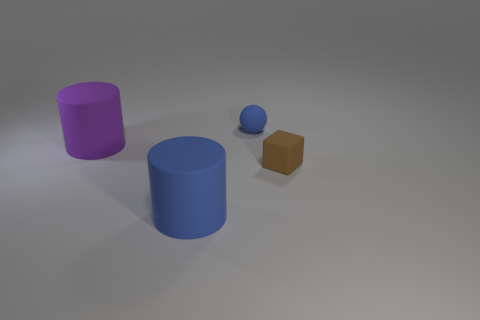There is a thing that is the same color as the matte sphere; what is its shape?
Offer a terse response. Cylinder. There is another object that is the same shape as the large blue rubber thing; what is it made of?
Give a very brief answer. Rubber. Do the matte cylinder that is in front of the brown thing and the tiny blue object have the same size?
Offer a very short reply. No. The matte object that is both in front of the blue rubber sphere and right of the blue matte cylinder is what color?
Ensure brevity in your answer.  Brown. There is a blue rubber thing behind the rubber block; how many tiny objects are right of it?
Keep it short and to the point. 1. Is the big blue object the same shape as the big purple object?
Your answer should be compact. Yes. Is there anything else that is the same color as the matte sphere?
Provide a succinct answer. Yes. Is the shape of the purple object the same as the large object that is right of the large purple thing?
Offer a terse response. Yes. There is a small rubber object to the right of the blue matte thing that is behind the big rubber cylinder that is to the right of the big purple cylinder; what is its color?
Your answer should be compact. Brown. Is the shape of the rubber object that is in front of the small brown rubber block the same as  the tiny blue matte object?
Offer a very short reply. No. 